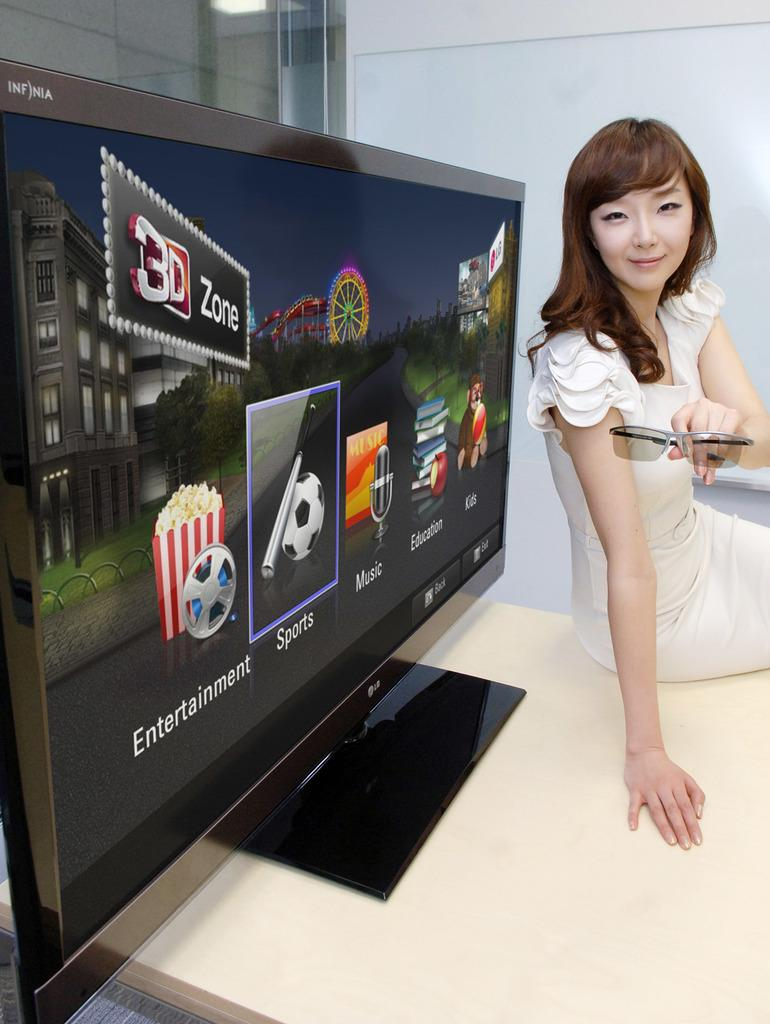Provide a one-sentence caption for the provided image. a woman in front of a monitor with icons for Entertainment and Sports. 